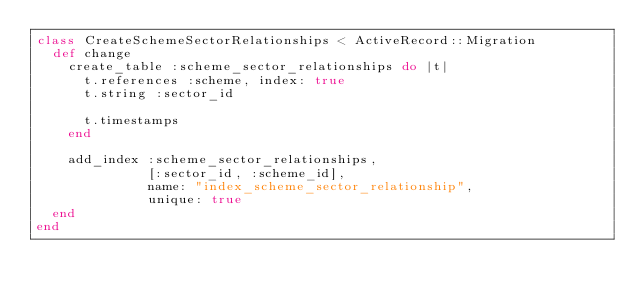Convert code to text. <code><loc_0><loc_0><loc_500><loc_500><_Ruby_>class CreateSchemeSectorRelationships < ActiveRecord::Migration
  def change
    create_table :scheme_sector_relationships do |t|
      t.references :scheme, index: true
      t.string :sector_id

      t.timestamps
    end

    add_index :scheme_sector_relationships,
              [:sector_id, :scheme_id],
              name: "index_scheme_sector_relationship",
              unique: true
  end
end
</code> 